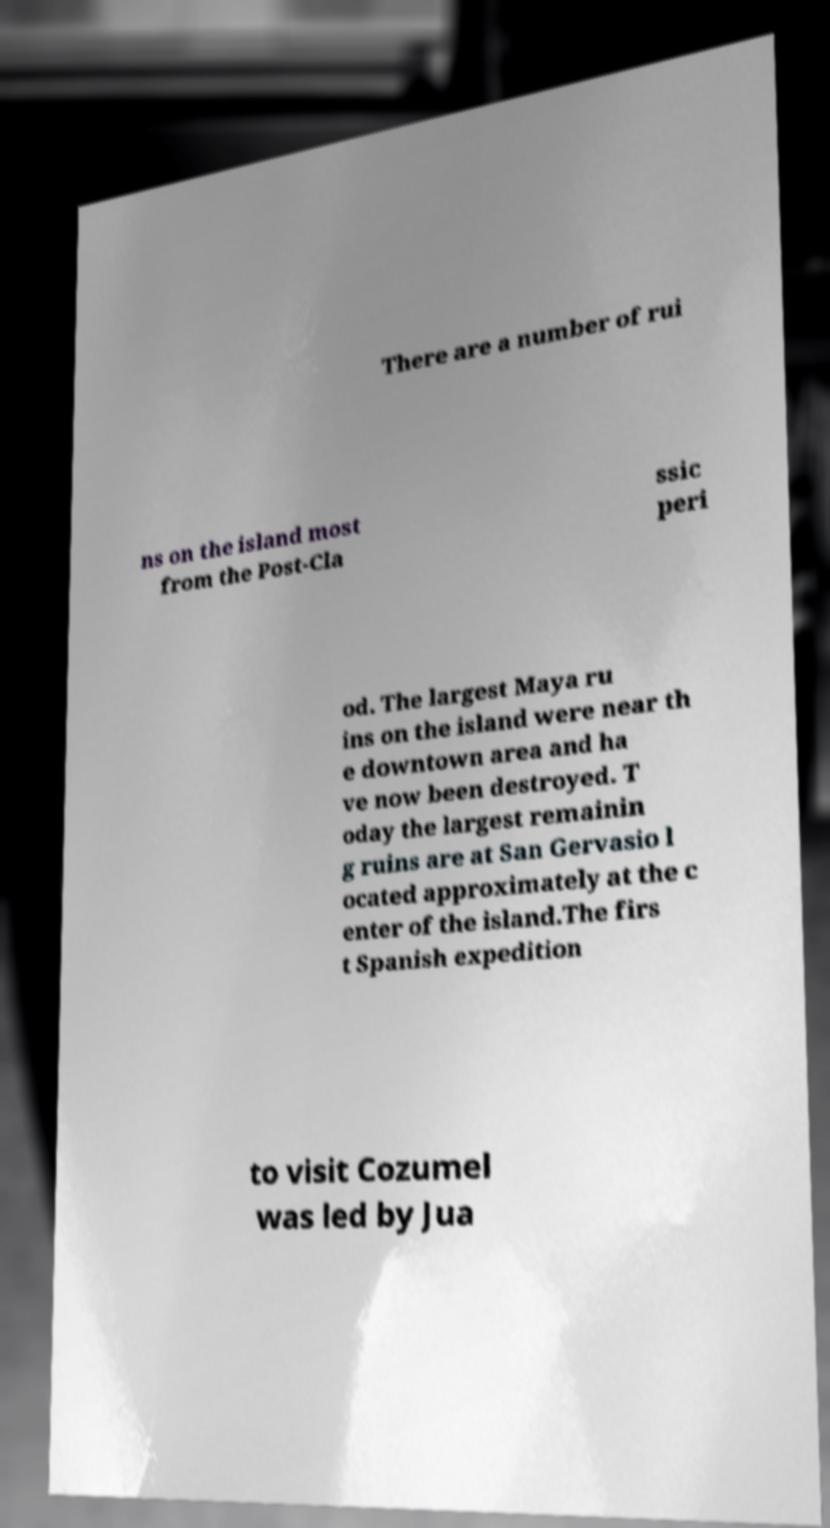Could you extract and type out the text from this image? There are a number of rui ns on the island most from the Post-Cla ssic peri od. The largest Maya ru ins on the island were near th e downtown area and ha ve now been destroyed. T oday the largest remainin g ruins are at San Gervasio l ocated approximately at the c enter of the island.The firs t Spanish expedition to visit Cozumel was led by Jua 